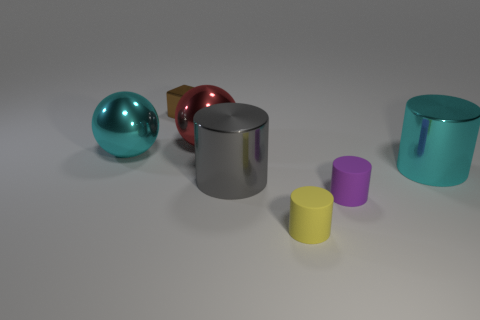Does the large shiny thing that is to the right of the large gray thing have the same shape as the large cyan metallic thing on the left side of the purple object?
Your answer should be very brief. No. Is the size of the gray cylinder the same as the cyan thing that is to the right of the small yellow thing?
Your answer should be compact. Yes. Are there more cyan cylinders than big brown metal spheres?
Provide a succinct answer. Yes. Is the material of the large cyan object to the left of the large gray metal cylinder the same as the cyan thing that is right of the big red metal object?
Give a very brief answer. Yes. What material is the brown thing?
Provide a short and direct response. Metal. Are there more big cyan shiny cylinders to the left of the gray thing than cyan balls?
Keep it short and to the point. No. There is a large thing that is in front of the big metallic cylinder on the right side of the gray metal cylinder; what number of brown things are on the left side of it?
Ensure brevity in your answer.  1. The cylinder that is both to the right of the small yellow matte cylinder and behind the purple rubber cylinder is made of what material?
Your answer should be very brief. Metal. The small shiny object is what color?
Offer a terse response. Brown. Are there more shiny objects that are to the left of the big cyan metal cylinder than red metallic objects right of the purple rubber object?
Offer a very short reply. Yes. 